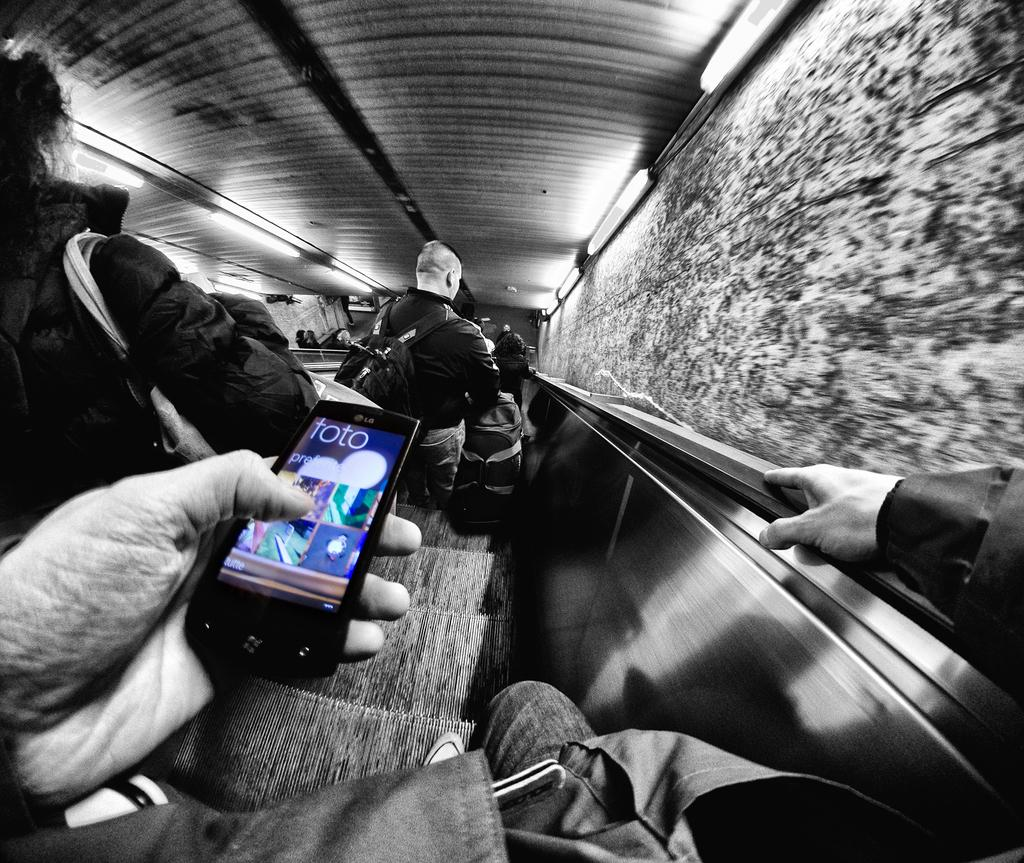What is the main subject of the image? There is a person in the image. What is the person holding in his hand? The person is holding a mobile in his hand. Where is the person located in the image? The person is on a staircase. What can be seen in the background of the image? There is a wall in the image. What type of ants can be seen crawling on the person's shoes in the image? There are no ants present in the image; the person is on a staircase holding a mobile. 